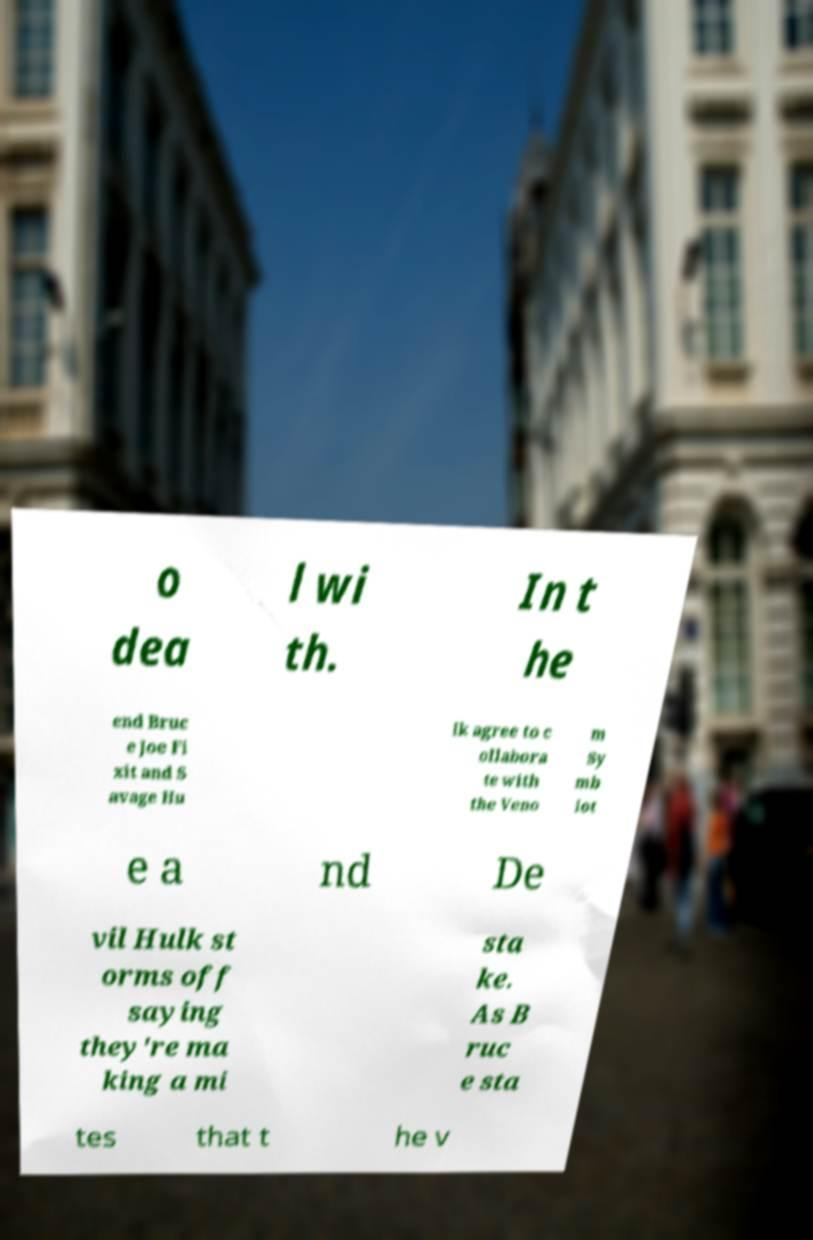I need the written content from this picture converted into text. Can you do that? o dea l wi th. In t he end Bruc e Joe Fi xit and S avage Hu lk agree to c ollabora te with the Veno m Sy mb iot e a nd De vil Hulk st orms off saying they're ma king a mi sta ke. As B ruc e sta tes that t he v 